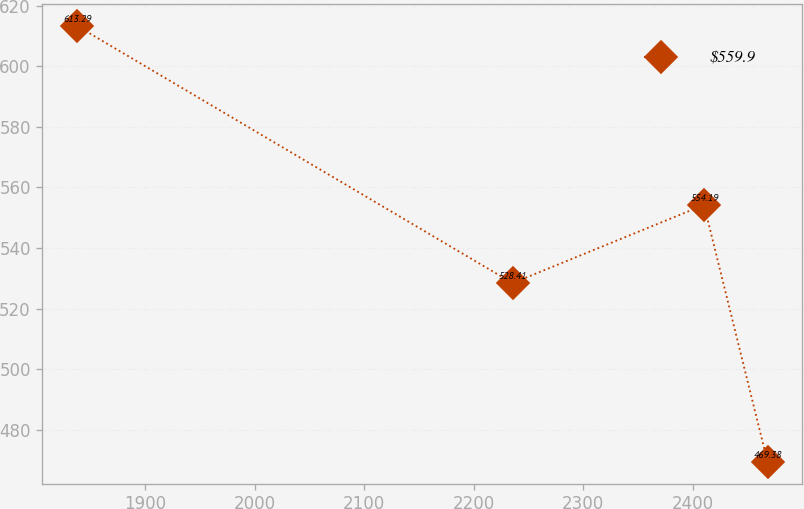Convert chart to OTSL. <chart><loc_0><loc_0><loc_500><loc_500><line_chart><ecel><fcel>$559.9<nl><fcel>1837.75<fcel>613.29<nl><fcel>2235.34<fcel>528.41<nl><fcel>2410.14<fcel>554.19<nl><fcel>2468.14<fcel>469.38<nl></chart> 